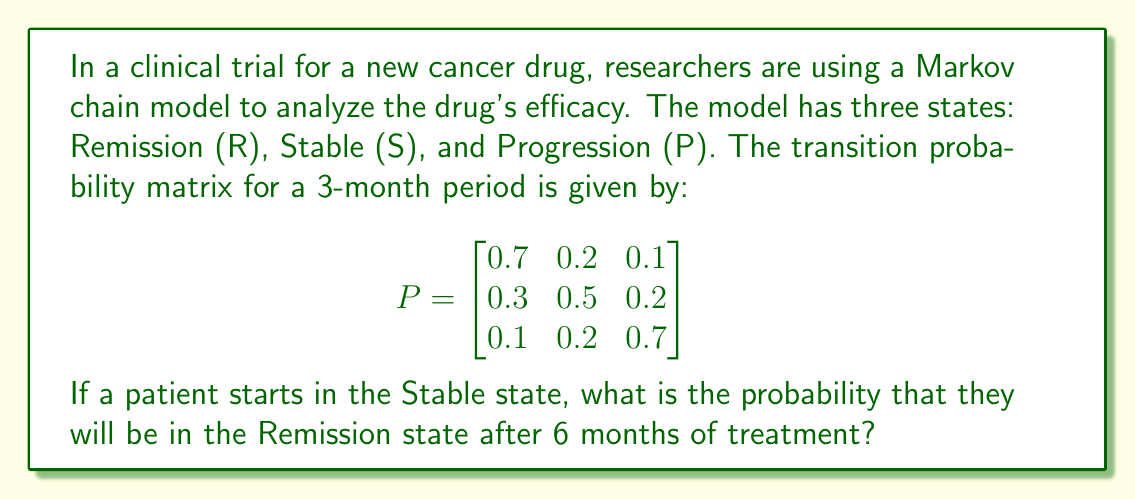Solve this math problem. To solve this problem, we need to follow these steps:

1) First, we need to calculate the transition probability matrix for a 6-month period. Since each transition in the given matrix represents a 3-month period, we need to square the matrix to get the 6-month transition probabilities.

2) Let's call the 6-month transition matrix $P^2$. We can calculate this as follows:

   $$
   P^2 = P \times P = \begin{bmatrix}
   0.7 & 0.2 & 0.1 \\
   0.3 & 0.5 & 0.2 \\
   0.1 & 0.2 & 0.7
   \end{bmatrix} \times \begin{bmatrix}
   0.7 & 0.2 & 0.1 \\
   0.3 & 0.5 & 0.2 \\
   0.1 & 0.2 & 0.7
   \end{bmatrix}
   $$

3) Performing the matrix multiplication:

   $$
   P^2 = \begin{bmatrix}
   0.56 & 0.27 & 0.17 \\
   0.37 & 0.38 & 0.25 \\
   0.22 & 0.29 & 0.49
   \end{bmatrix}
   $$

4) The patient starts in the Stable state, which corresponds to the second row of the matrix.

5) The probability of moving from Stable to Remission after 6 months is given by the element in the second row, first column of $P^2$.

6) This probability is 0.37 or 37%.
Answer: 0.37 